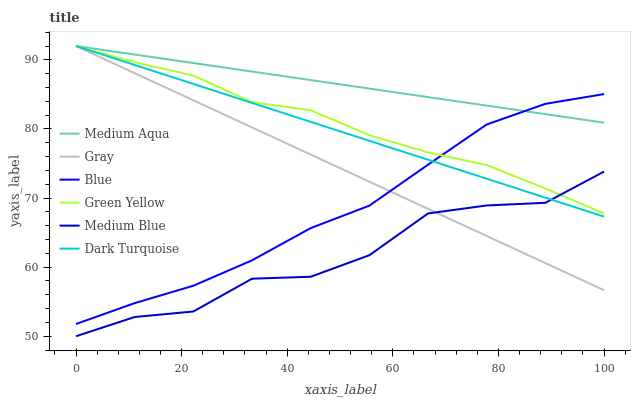Does Medium Blue have the minimum area under the curve?
Answer yes or no. Yes. Does Medium Aqua have the maximum area under the curve?
Answer yes or no. Yes. Does Gray have the minimum area under the curve?
Answer yes or no. No. Does Gray have the maximum area under the curve?
Answer yes or no. No. Is Gray the smoothest?
Answer yes or no. Yes. Is Medium Blue the roughest?
Answer yes or no. Yes. Is Dark Turquoise the smoothest?
Answer yes or no. No. Is Dark Turquoise the roughest?
Answer yes or no. No. Does Medium Blue have the lowest value?
Answer yes or no. Yes. Does Gray have the lowest value?
Answer yes or no. No. Does Green Yellow have the highest value?
Answer yes or no. Yes. Does Medium Blue have the highest value?
Answer yes or no. No. Is Medium Blue less than Medium Aqua?
Answer yes or no. Yes. Is Medium Aqua greater than Medium Blue?
Answer yes or no. Yes. Does Medium Blue intersect Gray?
Answer yes or no. Yes. Is Medium Blue less than Gray?
Answer yes or no. No. Is Medium Blue greater than Gray?
Answer yes or no. No. Does Medium Blue intersect Medium Aqua?
Answer yes or no. No. 